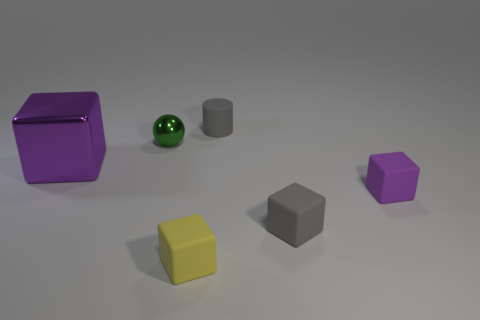Is there any other thing that has the same size as the purple shiny object?
Keep it short and to the point. No. There is a gray object that is in front of the small cylinder; what size is it?
Your answer should be very brief. Small. What number of other things are there of the same material as the ball
Your response must be concise. 1. Are there any tiny rubber blocks that are right of the purple cube that is in front of the big purple cube?
Your response must be concise. No. Are there any other things that are the same shape as the small purple rubber thing?
Offer a very short reply. Yes. There is a big shiny thing that is the same shape as the small purple rubber thing; what color is it?
Give a very brief answer. Purple. How big is the yellow object?
Offer a very short reply. Small. Is the number of matte things that are behind the green metal object less than the number of cyan matte objects?
Provide a short and direct response. No. Are the tiny cylinder and the small gray object that is in front of the ball made of the same material?
Offer a terse response. Yes. There is a metal object behind the shiny thing that is in front of the small metal sphere; are there any purple blocks that are behind it?
Your answer should be compact. No. 